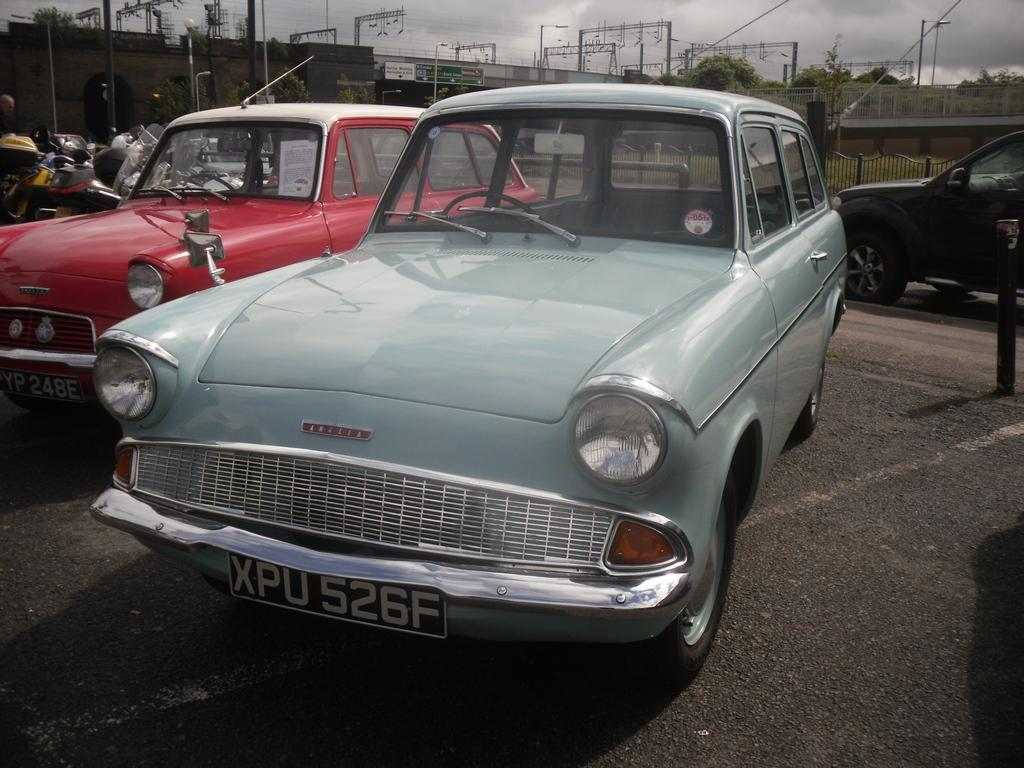What type of vehicles can be seen in the image? There are cars in the image. What is the purpose of the fence in the image? The purpose of the fence in the image is not explicitly stated, but it could be to mark a boundary or provide security. What type of structures are visible in the image? There are buildings in the image. What are the current poles used for? The current poles are used to transmit electricity. What part of the natural environment is visible in the image? The sky is visible in the image. Can you tell me how many boots are hanging from the current poles in the image? There are no boots present in the image; it features cars, a fence, buildings, current poles, and the sky. What type of driving is taking place in the image? There is no driving taking place in the image; it only shows cars, a fence, buildings, current poles, and the sky. 